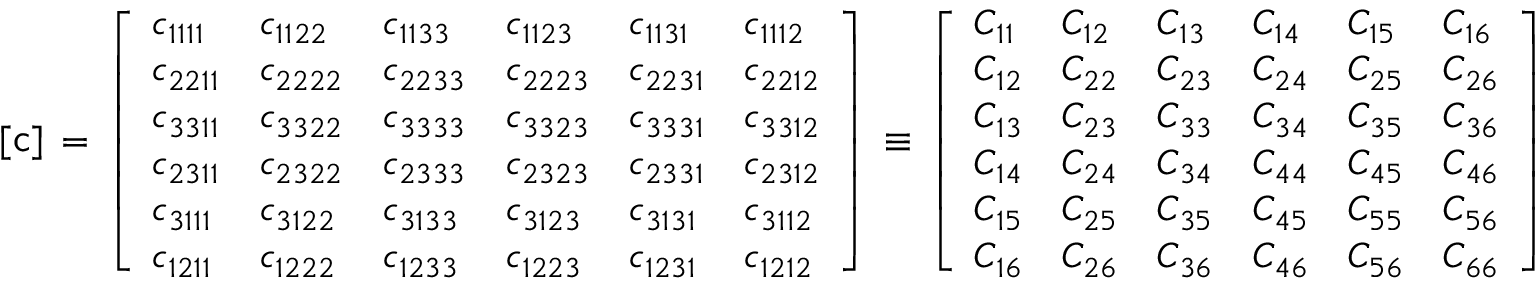Convert formula to latex. <formula><loc_0><loc_0><loc_500><loc_500>[ { c } ] \, = \, { \left [ \begin{array} { l l l l l l } { c _ { 1 1 1 1 } } & { c _ { 1 1 2 2 } } & { c _ { 1 1 3 3 } } & { c _ { 1 1 2 3 } } & { c _ { 1 1 3 1 } } & { c _ { 1 1 1 2 } } \\ { c _ { 2 2 1 1 } } & { c _ { 2 2 2 2 } } & { c _ { 2 2 3 3 } } & { c _ { 2 2 2 3 } } & { c _ { 2 2 3 1 } } & { c _ { 2 2 1 2 } } \\ { c _ { 3 3 1 1 } } & { c _ { 3 3 2 2 } } & { c _ { 3 3 3 3 } } & { c _ { 3 3 2 3 } } & { c _ { 3 3 3 1 } } & { c _ { 3 3 1 2 } } \\ { c _ { 2 3 1 1 } } & { c _ { 2 3 2 2 } } & { c _ { 2 3 3 3 } } & { c _ { 2 3 2 3 } } & { c _ { 2 3 3 1 } } & { c _ { 2 3 1 2 } } \\ { c _ { 3 1 1 1 } } & { c _ { 3 1 2 2 } } & { c _ { 3 1 3 3 } } & { c _ { 3 1 2 3 } } & { c _ { 3 1 3 1 } } & { c _ { 3 1 1 2 } } \\ { c _ { 1 2 1 1 } } & { c _ { 1 2 2 2 } } & { c _ { 1 2 3 3 } } & { c _ { 1 2 2 3 } } & { c _ { 1 2 3 1 } } & { c _ { 1 2 1 2 } } \end{array} \right ] } \, \equiv \, { \left [ \begin{array} { l l l l l l } { C _ { 1 1 } } & { C _ { 1 2 } } & { C _ { 1 3 } } & { C _ { 1 4 } } & { C _ { 1 5 } } & { C _ { 1 6 } } \\ { C _ { 1 2 } } & { C _ { 2 2 } } & { C _ { 2 3 } } & { C _ { 2 4 } } & { C _ { 2 5 } } & { C _ { 2 6 } } \\ { C _ { 1 3 } } & { C _ { 2 3 } } & { C _ { 3 3 } } & { C _ { 3 4 } } & { C _ { 3 5 } } & { C _ { 3 6 } } \\ { C _ { 1 4 } } & { C _ { 2 4 } } & { C _ { 3 4 } } & { C _ { 4 4 } } & { C _ { 4 5 } } & { C _ { 4 6 } } \\ { C _ { 1 5 } } & { C _ { 2 5 } } & { C _ { 3 5 } } & { C _ { 4 5 } } & { C _ { 5 5 } } & { C _ { 5 6 } } \\ { C _ { 1 6 } } & { C _ { 2 6 } } & { C _ { 3 6 } } & { C _ { 4 6 } } & { C _ { 5 6 } } & { C _ { 6 6 } } \end{array} \right ] }</formula> 